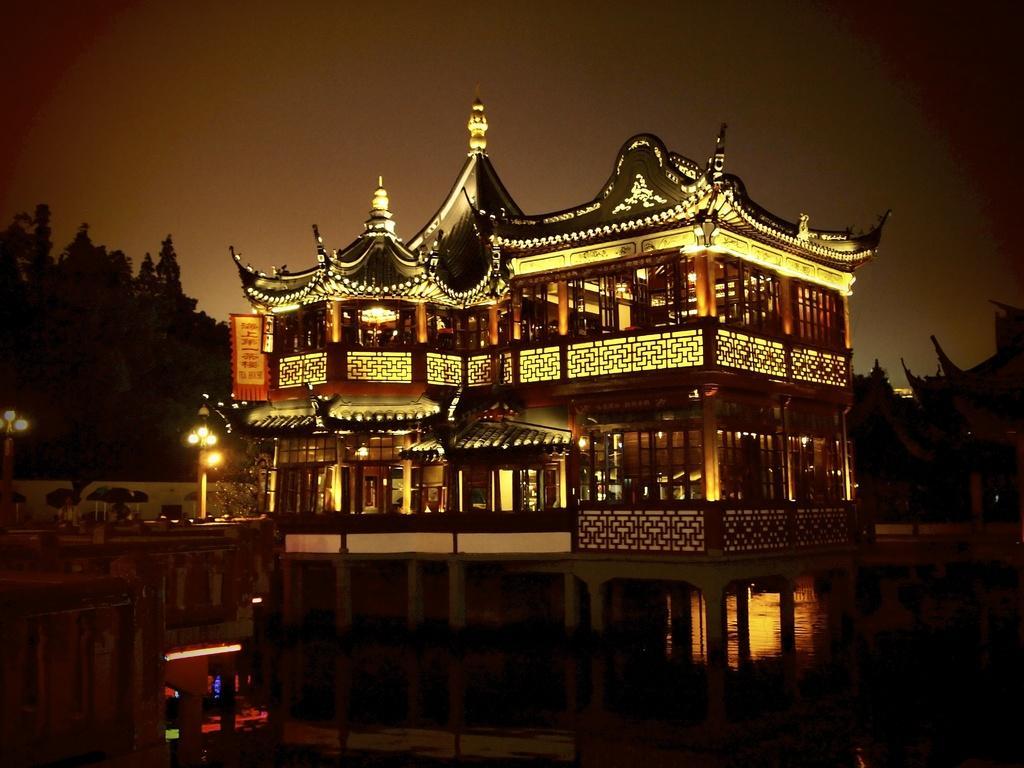In one or two sentences, can you explain what this image depicts? In this image we can see a palace, sky, street poles, street lights, water and trees. 